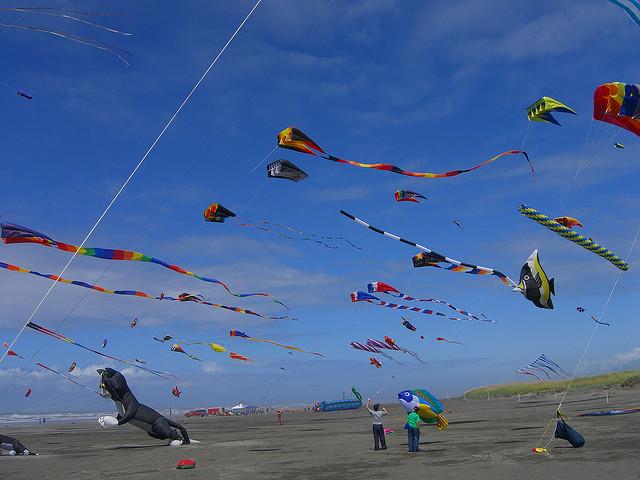Is there an animal trying to fly a kite?
Concise answer only. No. What are the objects flying in the sky?
Concise answer only. Kites. Are there a lot of kites?
Give a very brief answer. Yes. How many kites in the sky?
Be succinct. 20. 